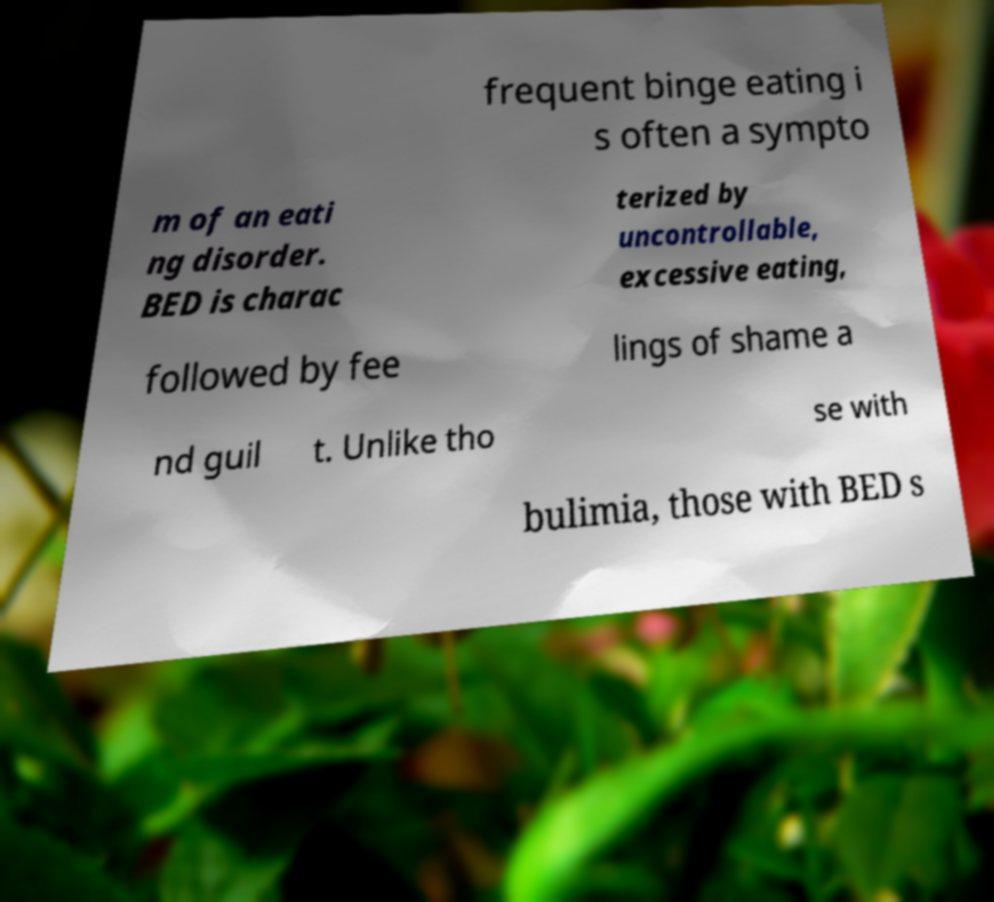What messages or text are displayed in this image? I need them in a readable, typed format. frequent binge eating i s often a sympto m of an eati ng disorder. BED is charac terized by uncontrollable, excessive eating, followed by fee lings of shame a nd guil t. Unlike tho se with bulimia, those with BED s 